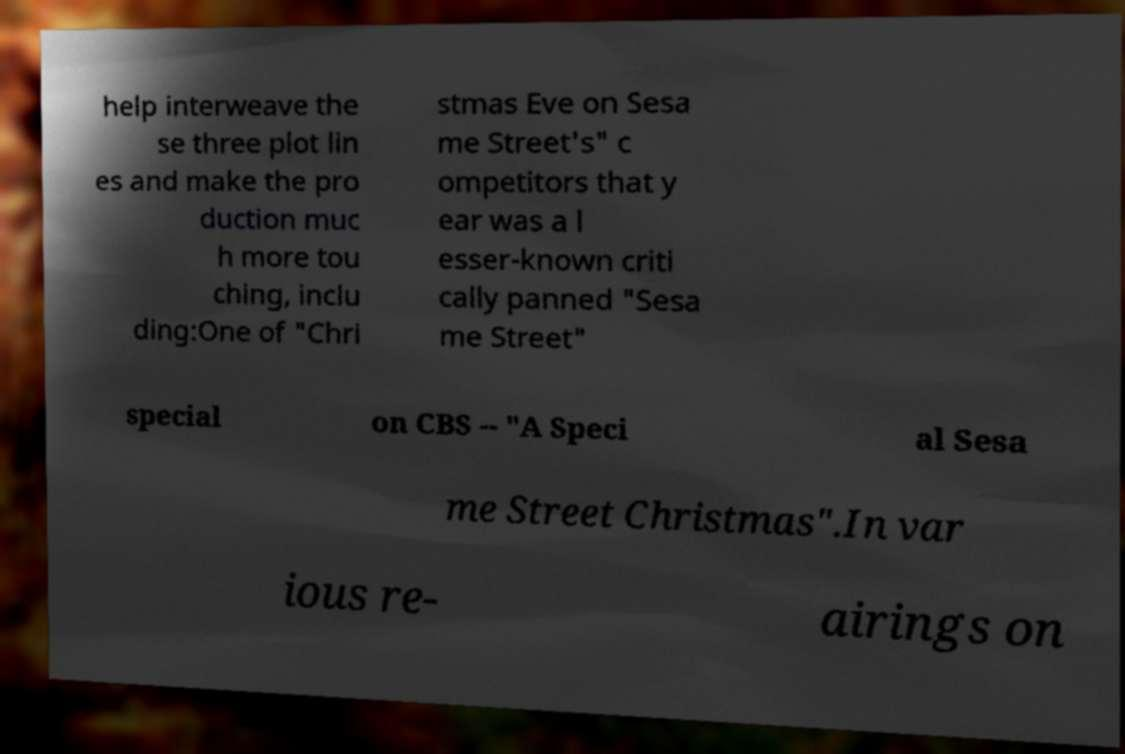Please read and relay the text visible in this image. What does it say? help interweave the se three plot lin es and make the pro duction muc h more tou ching, inclu ding:One of "Chri stmas Eve on Sesa me Street's" c ompetitors that y ear was a l esser-known criti cally panned "Sesa me Street" special on CBS -- "A Speci al Sesa me Street Christmas".In var ious re- airings on 